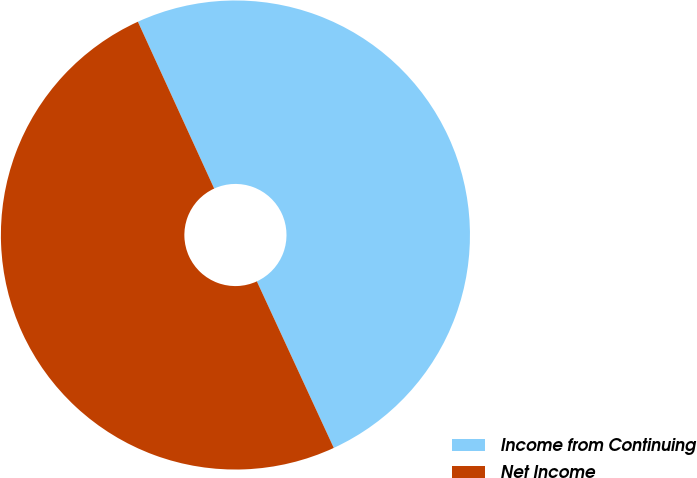Convert chart. <chart><loc_0><loc_0><loc_500><loc_500><pie_chart><fcel>Income from Continuing<fcel>Net Income<nl><fcel>49.94%<fcel>50.06%<nl></chart> 